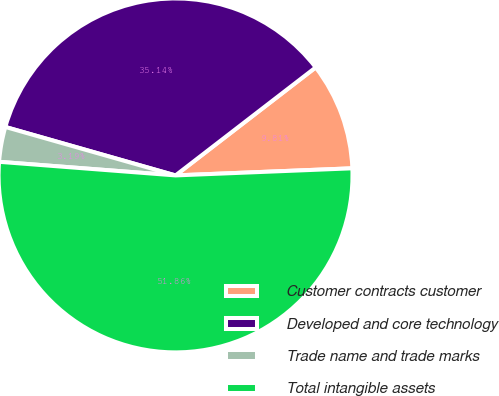Convert chart to OTSL. <chart><loc_0><loc_0><loc_500><loc_500><pie_chart><fcel>Customer contracts customer<fcel>Developed and core technology<fcel>Trade name and trade marks<fcel>Total intangible assets<nl><fcel>9.81%<fcel>35.14%<fcel>3.19%<fcel>51.87%<nl></chart> 